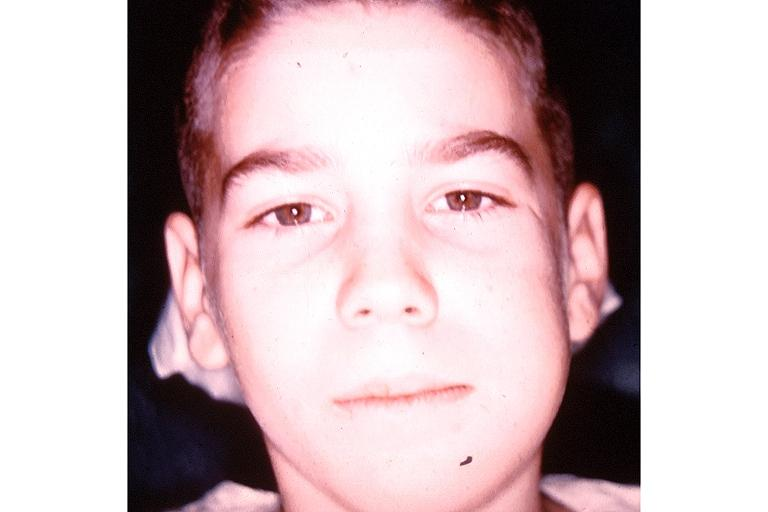s feet present?
Answer the question using a single word or phrase. No 